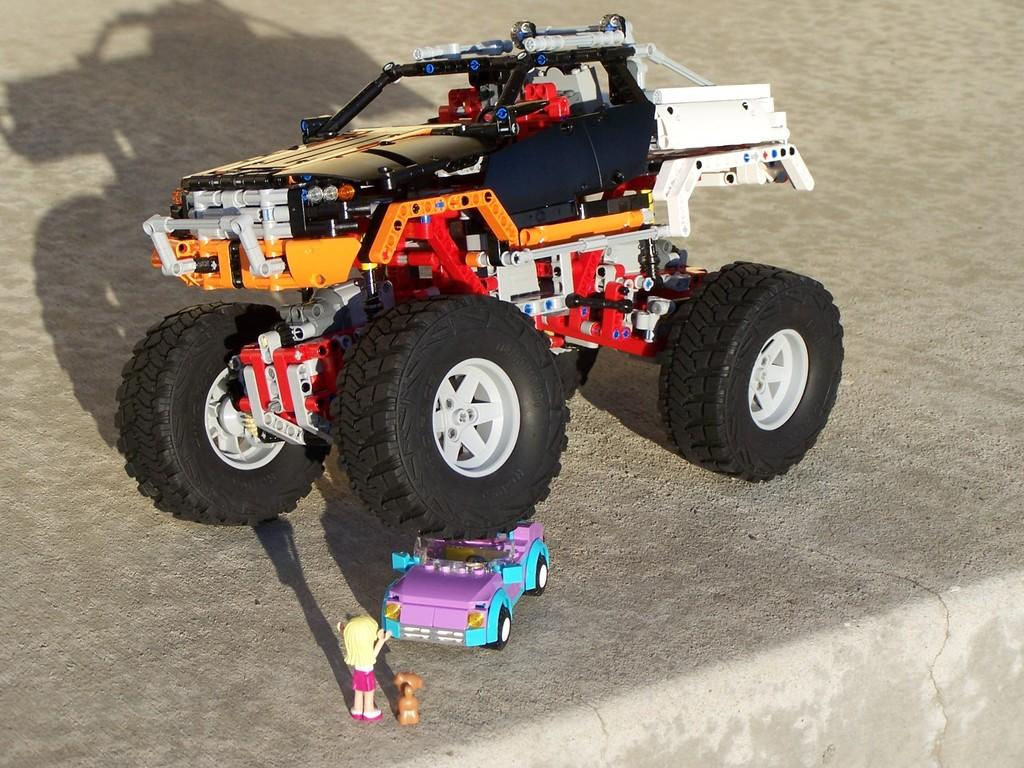What objects are present in the image? There are toys in the image. Where are the toys located? The toys are on a surface. How many boats are visible in the image? There are no boats present in the image. 